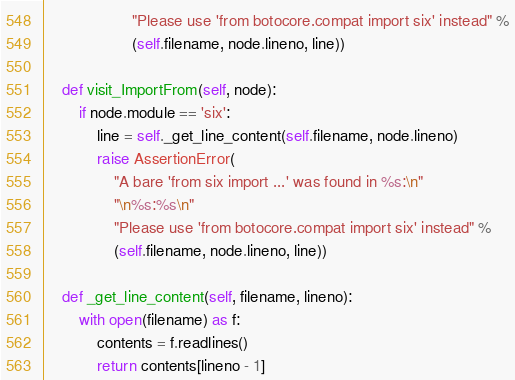<code> <loc_0><loc_0><loc_500><loc_500><_Python_>                    "Please use 'from botocore.compat import six' instead" %
                    (self.filename, node.lineno, line))

    def visit_ImportFrom(self, node):
        if node.module == 'six':
            line = self._get_line_content(self.filename, node.lineno)
            raise AssertionError(
                "A bare 'from six import ...' was found in %s:\n"
                "\n%s:%s\n"
                "Please use 'from botocore.compat import six' instead" %
                (self.filename, node.lineno, line))

    def _get_line_content(self, filename, lineno):
        with open(filename) as f:
            contents = f.readlines()
            return contents[lineno - 1]
</code> 